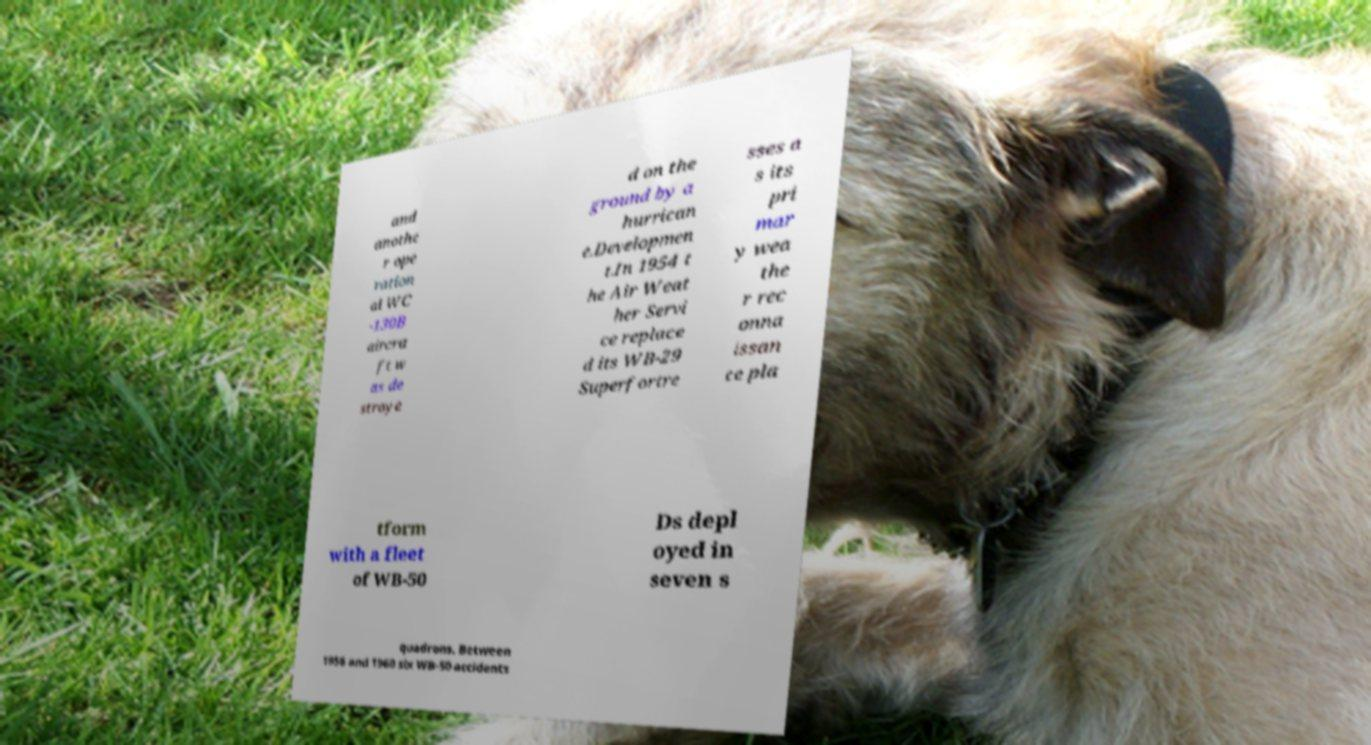Please read and relay the text visible in this image. What does it say? and anothe r ope ration al WC -130B aircra ft w as de stroye d on the ground by a hurrican e.Developmen t.In 1954 t he Air Weat her Servi ce replace d its WB-29 Superfortre sses a s its pri mar y wea the r rec onna issan ce pla tform with a fleet of WB-50 Ds depl oyed in seven s quadrons. Between 1956 and 1960 six WB-50 accidents 